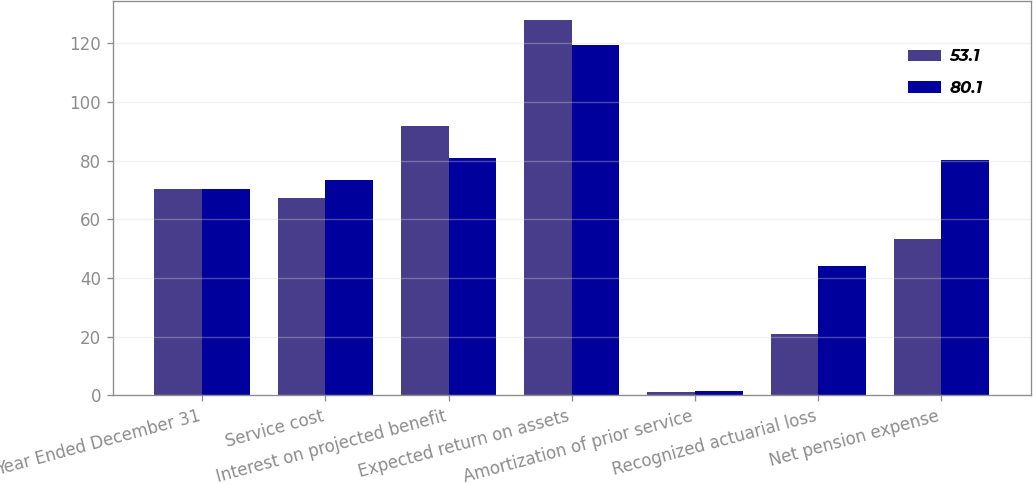Convert chart. <chart><loc_0><loc_0><loc_500><loc_500><stacked_bar_chart><ecel><fcel>Year Ended December 31<fcel>Service cost<fcel>Interest on projected benefit<fcel>Expected return on assets<fcel>Amortization of prior service<fcel>Recognized actuarial loss<fcel>Net pension expense<nl><fcel>53.1<fcel>70.4<fcel>67.3<fcel>91.8<fcel>128<fcel>1.2<fcel>20.8<fcel>53.1<nl><fcel>80.1<fcel>70.4<fcel>73.5<fcel>81<fcel>119.4<fcel>1.3<fcel>44<fcel>80.1<nl></chart> 